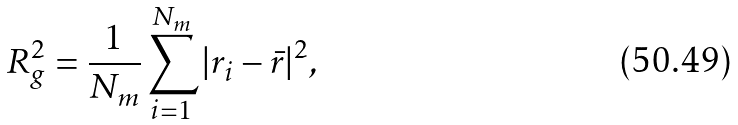Convert formula to latex. <formula><loc_0><loc_0><loc_500><loc_500>R _ { g } ^ { 2 } = \frac { 1 } { N _ { m } } \sum _ { i = 1 } ^ { N _ { m } } | { r } _ { i } - { \bar { r } } | ^ { 2 } ,</formula> 